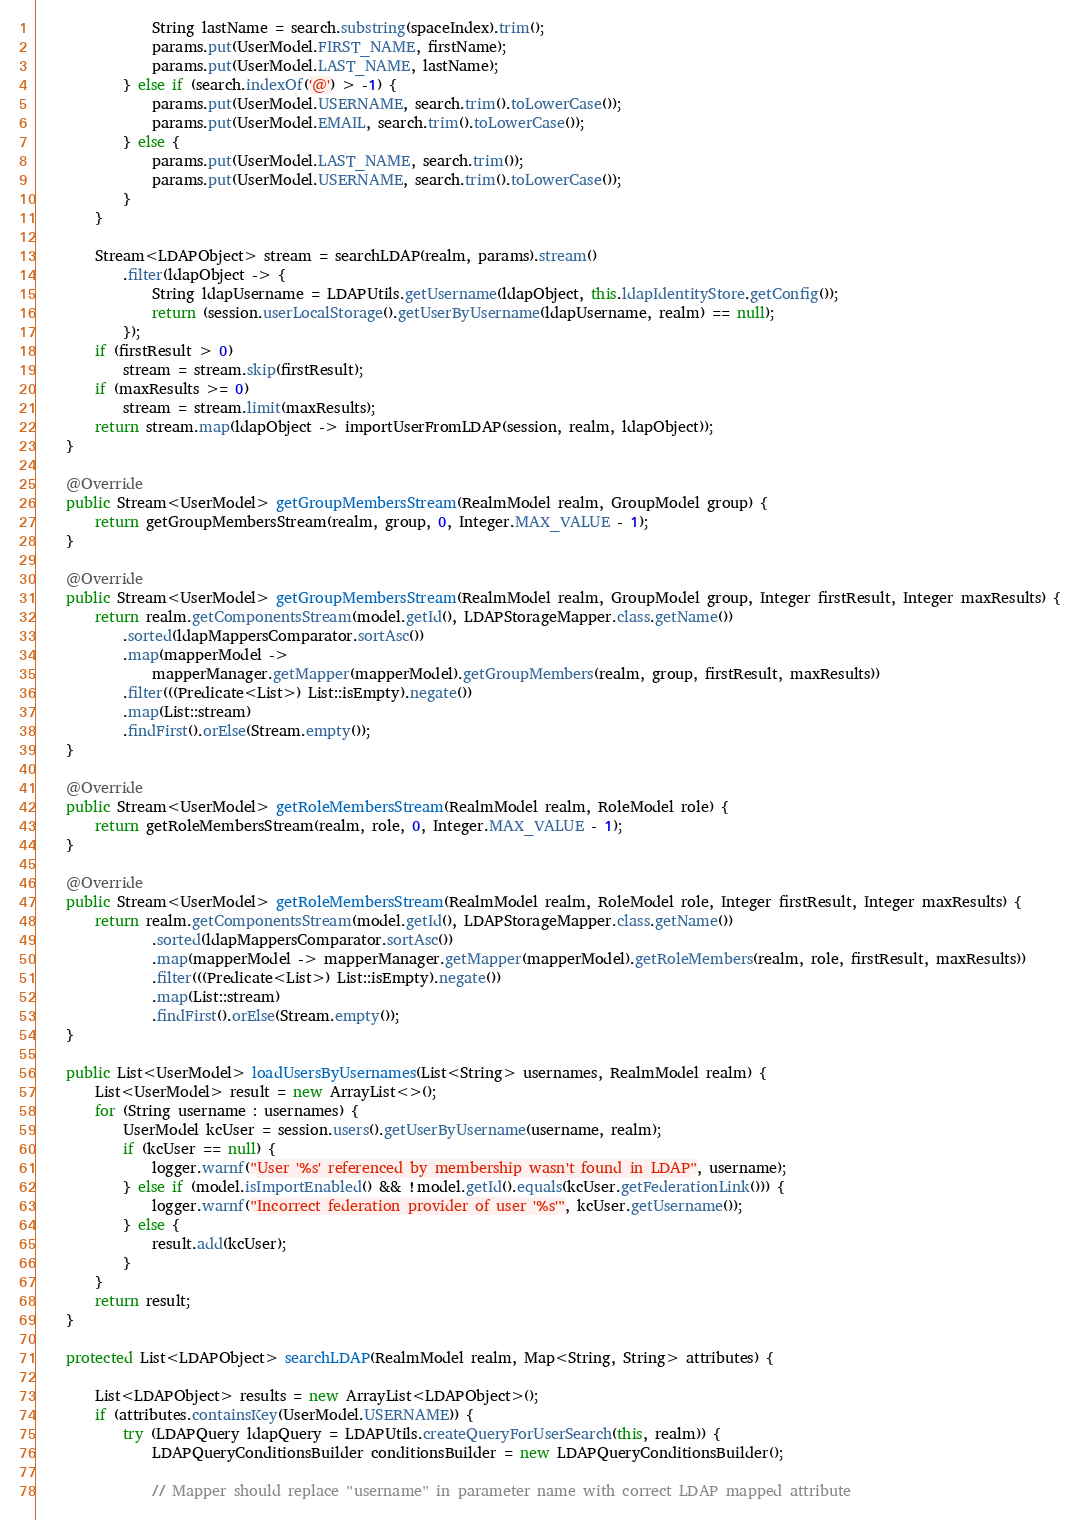<code> <loc_0><loc_0><loc_500><loc_500><_Java_>                String lastName = search.substring(spaceIndex).trim();
                params.put(UserModel.FIRST_NAME, firstName);
                params.put(UserModel.LAST_NAME, lastName);
            } else if (search.indexOf('@') > -1) {
                params.put(UserModel.USERNAME, search.trim().toLowerCase());
                params.put(UserModel.EMAIL, search.trim().toLowerCase());
            } else {
                params.put(UserModel.LAST_NAME, search.trim());
                params.put(UserModel.USERNAME, search.trim().toLowerCase());
            }
        }

        Stream<LDAPObject> stream = searchLDAP(realm, params).stream()
            .filter(ldapObject -> {
                String ldapUsername = LDAPUtils.getUsername(ldapObject, this.ldapIdentityStore.getConfig());
                return (session.userLocalStorage().getUserByUsername(ldapUsername, realm) == null);
            });
        if (firstResult > 0)
            stream = stream.skip(firstResult);
        if (maxResults >= 0)
            stream = stream.limit(maxResults);
        return stream.map(ldapObject -> importUserFromLDAP(session, realm, ldapObject));
    }

    @Override
    public Stream<UserModel> getGroupMembersStream(RealmModel realm, GroupModel group) {
        return getGroupMembersStream(realm, group, 0, Integer.MAX_VALUE - 1);
    }

    @Override
    public Stream<UserModel> getGroupMembersStream(RealmModel realm, GroupModel group, Integer firstResult, Integer maxResults) {
        return realm.getComponentsStream(model.getId(), LDAPStorageMapper.class.getName())
            .sorted(ldapMappersComparator.sortAsc())
            .map(mapperModel ->
                mapperManager.getMapper(mapperModel).getGroupMembers(realm, group, firstResult, maxResults))
            .filter(((Predicate<List>) List::isEmpty).negate())
            .map(List::stream)
            .findFirst().orElse(Stream.empty());
    }

    @Override
    public Stream<UserModel> getRoleMembersStream(RealmModel realm, RoleModel role) {
        return getRoleMembersStream(realm, role, 0, Integer.MAX_VALUE - 1);
    }

    @Override
    public Stream<UserModel> getRoleMembersStream(RealmModel realm, RoleModel role, Integer firstResult, Integer maxResults) {
        return realm.getComponentsStream(model.getId(), LDAPStorageMapper.class.getName())
                .sorted(ldapMappersComparator.sortAsc())
                .map(mapperModel -> mapperManager.getMapper(mapperModel).getRoleMembers(realm, role, firstResult, maxResults))
                .filter(((Predicate<List>) List::isEmpty).negate())
                .map(List::stream)
                .findFirst().orElse(Stream.empty());
    }

    public List<UserModel> loadUsersByUsernames(List<String> usernames, RealmModel realm) {
        List<UserModel> result = new ArrayList<>();
        for (String username : usernames) {
            UserModel kcUser = session.users().getUserByUsername(username, realm);
            if (kcUser == null) {
                logger.warnf("User '%s' referenced by membership wasn't found in LDAP", username);
            } else if (model.isImportEnabled() && !model.getId().equals(kcUser.getFederationLink())) {
                logger.warnf("Incorrect federation provider of user '%s'", kcUser.getUsername());
            } else {
                result.add(kcUser);
            }
        }
        return result;
    }

    protected List<LDAPObject> searchLDAP(RealmModel realm, Map<String, String> attributes) {

        List<LDAPObject> results = new ArrayList<LDAPObject>();
        if (attributes.containsKey(UserModel.USERNAME)) {
            try (LDAPQuery ldapQuery = LDAPUtils.createQueryForUserSearch(this, realm)) {
                LDAPQueryConditionsBuilder conditionsBuilder = new LDAPQueryConditionsBuilder();

                // Mapper should replace "username" in parameter name with correct LDAP mapped attribute</code> 